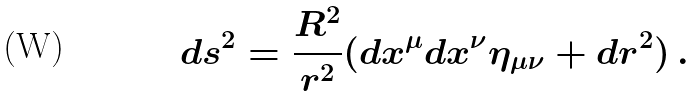Convert formula to latex. <formula><loc_0><loc_0><loc_500><loc_500>d s ^ { 2 } = \frac { R ^ { 2 } } { r ^ { 2 } } ( d x ^ { \mu } d x ^ { \nu } \eta _ { \mu \nu } + d r ^ { 2 } ) \, .</formula> 